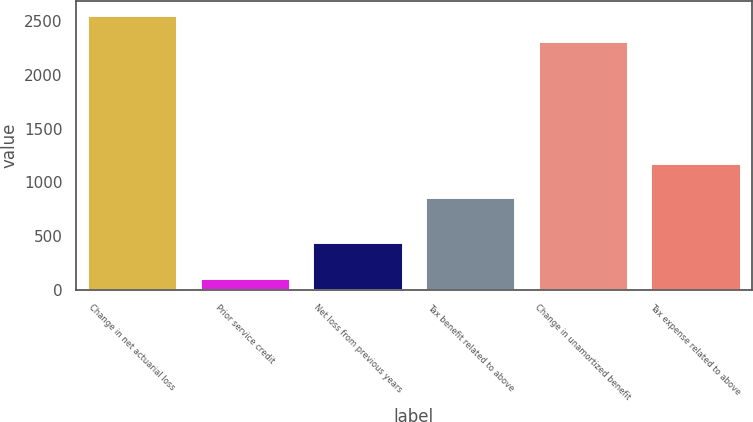<chart> <loc_0><loc_0><loc_500><loc_500><bar_chart><fcel>Change in net actuarial loss<fcel>Prior service credit<fcel>Net loss from previous years<fcel>Tax benefit related to above<fcel>Change in unamortized benefit<fcel>Tax expense related to above<nl><fcel>2555.5<fcel>109<fcel>448<fcel>860<fcel>2316<fcel>1177<nl></chart> 